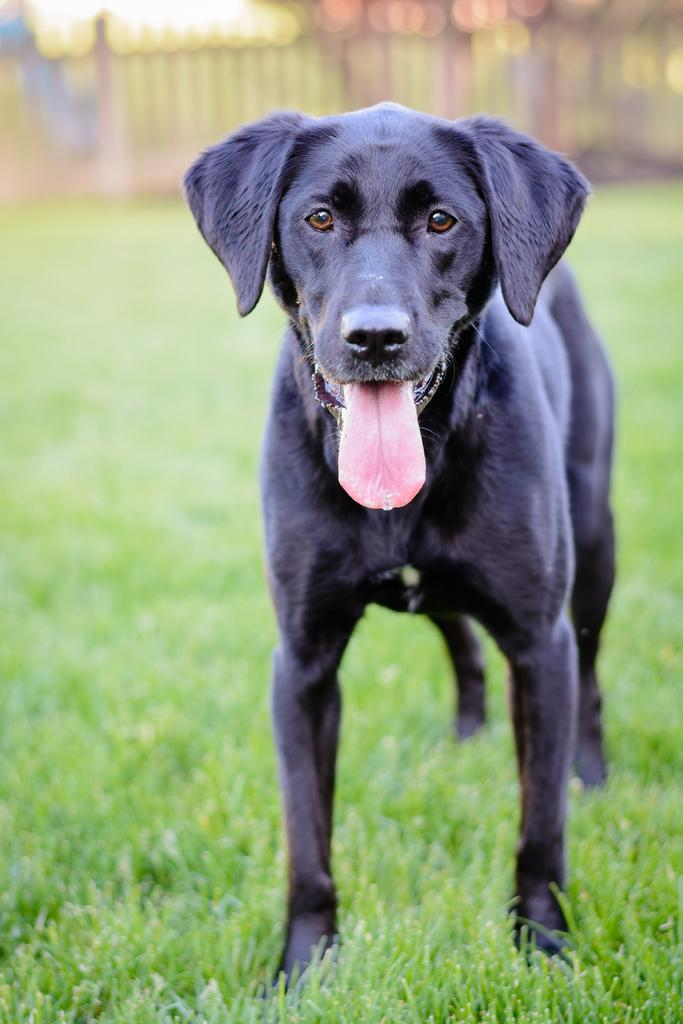What animal is present in the image? There is a dog in the image. What is the dog standing on? The dog is standing on the grass. What type of seat is the dog using in the image? There is no seat present in the image, as the dog is standing on the grass. 